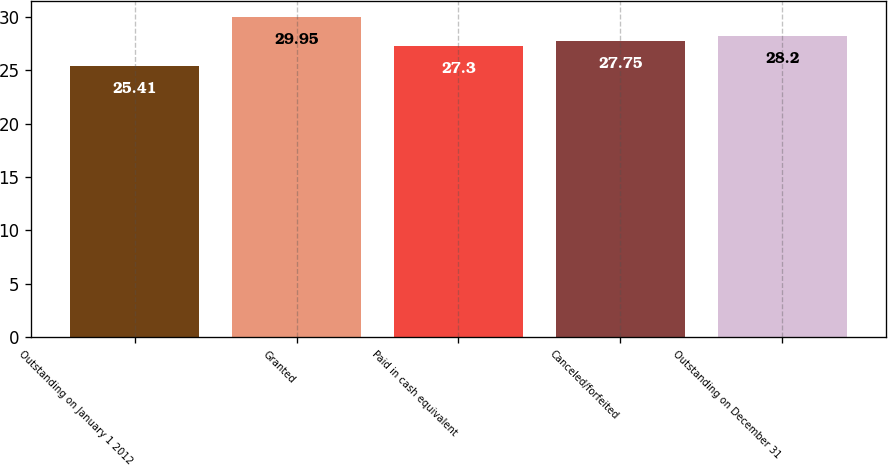Convert chart. <chart><loc_0><loc_0><loc_500><loc_500><bar_chart><fcel>Outstanding on January 1 2012<fcel>Granted<fcel>Paid in cash equivalent<fcel>Canceled/forfeited<fcel>Outstanding on December 31<nl><fcel>25.41<fcel>29.95<fcel>27.3<fcel>27.75<fcel>28.2<nl></chart> 